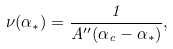Convert formula to latex. <formula><loc_0><loc_0><loc_500><loc_500>\nu ( \alpha _ { * } ) = \frac { 1 } { A ^ { \prime \prime } ( \alpha _ { c } - \alpha _ { * } ) } ,</formula> 